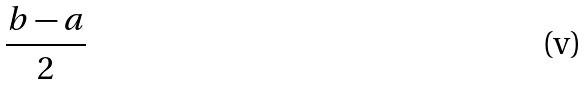Convert formula to latex. <formula><loc_0><loc_0><loc_500><loc_500>\frac { b - a } { 2 }</formula> 